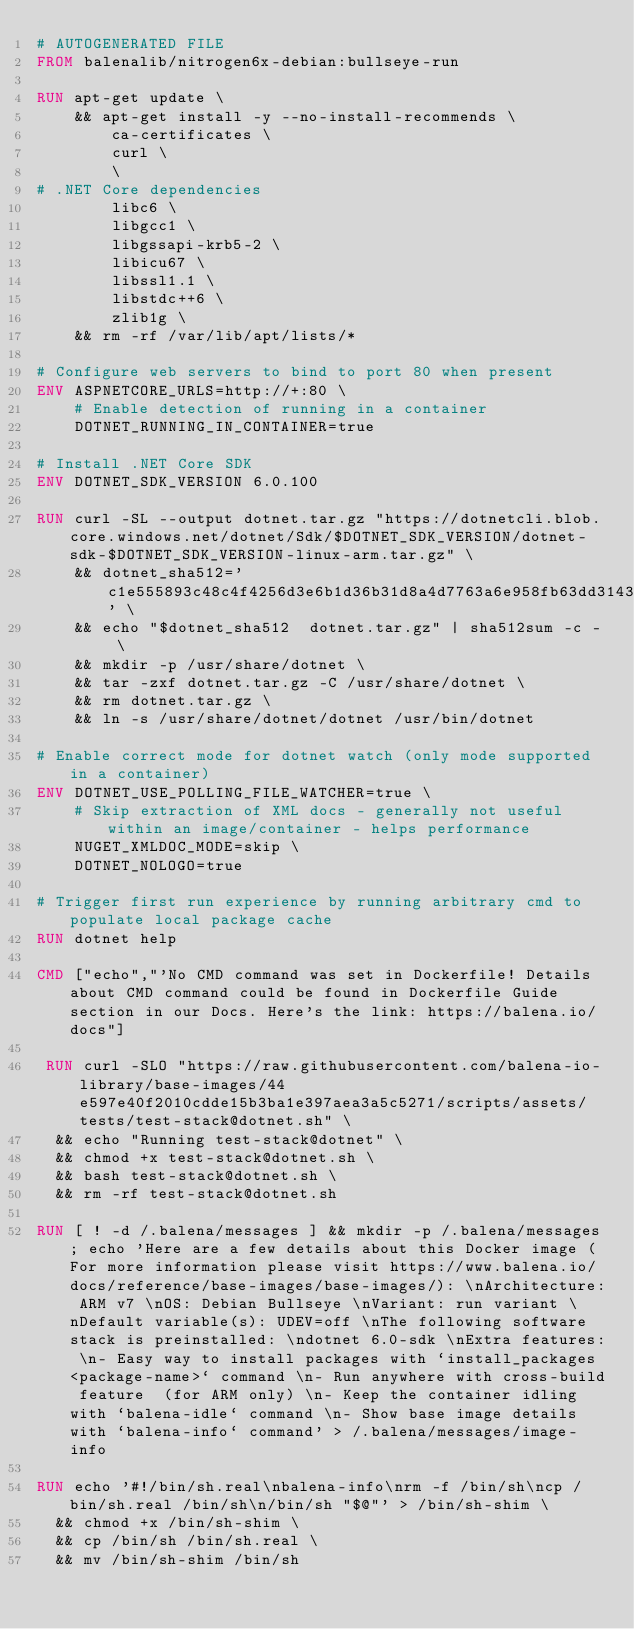<code> <loc_0><loc_0><loc_500><loc_500><_Dockerfile_># AUTOGENERATED FILE
FROM balenalib/nitrogen6x-debian:bullseye-run

RUN apt-get update \
    && apt-get install -y --no-install-recommends \
        ca-certificates \
        curl \
        \
# .NET Core dependencies
        libc6 \
        libgcc1 \
        libgssapi-krb5-2 \
        libicu67 \
        libssl1.1 \
        libstdc++6 \
        zlib1g \
    && rm -rf /var/lib/apt/lists/*

# Configure web servers to bind to port 80 when present
ENV ASPNETCORE_URLS=http://+:80 \
    # Enable detection of running in a container
    DOTNET_RUNNING_IN_CONTAINER=true

# Install .NET Core SDK
ENV DOTNET_SDK_VERSION 6.0.100

RUN curl -SL --output dotnet.tar.gz "https://dotnetcli.blob.core.windows.net/dotnet/Sdk/$DOTNET_SDK_VERSION/dotnet-sdk-$DOTNET_SDK_VERSION-linux-arm.tar.gz" \
    && dotnet_sha512='c1e555893c48c4f4256d3e6b1d36b31d8a4d7763a6e958fb63dd31436c660648d481612b5e25d79a613e84a1954f5eac2c9c2b740bf410958172780f7bbeaeb3' \
    && echo "$dotnet_sha512  dotnet.tar.gz" | sha512sum -c - \
    && mkdir -p /usr/share/dotnet \
    && tar -zxf dotnet.tar.gz -C /usr/share/dotnet \
    && rm dotnet.tar.gz \
    && ln -s /usr/share/dotnet/dotnet /usr/bin/dotnet

# Enable correct mode for dotnet watch (only mode supported in a container)
ENV DOTNET_USE_POLLING_FILE_WATCHER=true \
    # Skip extraction of XML docs - generally not useful within an image/container - helps performance
    NUGET_XMLDOC_MODE=skip \
    DOTNET_NOLOGO=true

# Trigger first run experience by running arbitrary cmd to populate local package cache
RUN dotnet help

CMD ["echo","'No CMD command was set in Dockerfile! Details about CMD command could be found in Dockerfile Guide section in our Docs. Here's the link: https://balena.io/docs"]

 RUN curl -SLO "https://raw.githubusercontent.com/balena-io-library/base-images/44e597e40f2010cdde15b3ba1e397aea3a5c5271/scripts/assets/tests/test-stack@dotnet.sh" \
  && echo "Running test-stack@dotnet" \
  && chmod +x test-stack@dotnet.sh \
  && bash test-stack@dotnet.sh \
  && rm -rf test-stack@dotnet.sh 

RUN [ ! -d /.balena/messages ] && mkdir -p /.balena/messages; echo 'Here are a few details about this Docker image (For more information please visit https://www.balena.io/docs/reference/base-images/base-images/): \nArchitecture: ARM v7 \nOS: Debian Bullseye \nVariant: run variant \nDefault variable(s): UDEV=off \nThe following software stack is preinstalled: \ndotnet 6.0-sdk \nExtra features: \n- Easy way to install packages with `install_packages <package-name>` command \n- Run anywhere with cross-build feature  (for ARM only) \n- Keep the container idling with `balena-idle` command \n- Show base image details with `balena-info` command' > /.balena/messages/image-info

RUN echo '#!/bin/sh.real\nbalena-info\nrm -f /bin/sh\ncp /bin/sh.real /bin/sh\n/bin/sh "$@"' > /bin/sh-shim \
	&& chmod +x /bin/sh-shim \
	&& cp /bin/sh /bin/sh.real \
	&& mv /bin/sh-shim /bin/sh</code> 